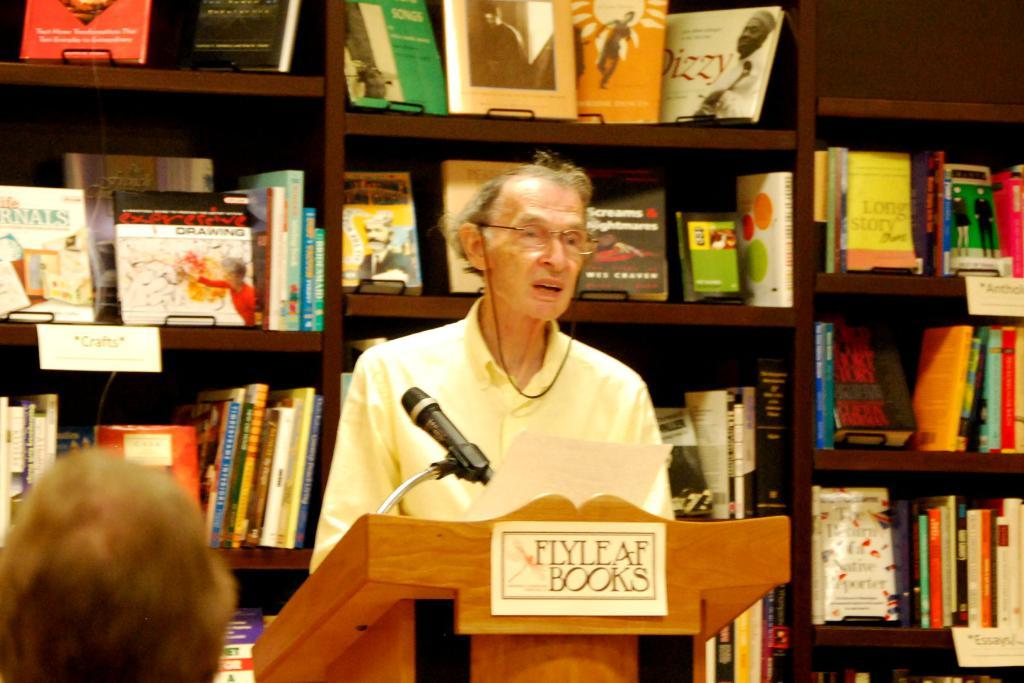<image>
Offer a succinct explanation of the picture presented. A man speaks from behind a podium at Flyleaf Books. 